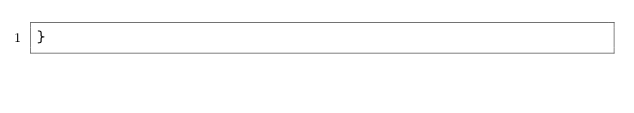Convert code to text. <code><loc_0><loc_0><loc_500><loc_500><_Swift_>}
</code> 